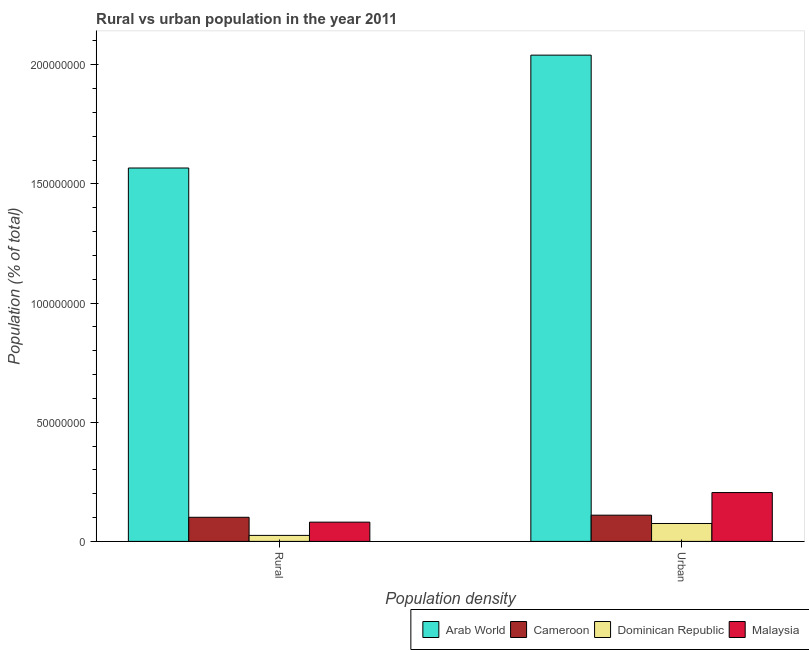How many different coloured bars are there?
Provide a short and direct response. 4. How many groups of bars are there?
Offer a terse response. 2. Are the number of bars per tick equal to the number of legend labels?
Offer a very short reply. Yes. How many bars are there on the 2nd tick from the left?
Your answer should be compact. 4. How many bars are there on the 2nd tick from the right?
Provide a succinct answer. 4. What is the label of the 1st group of bars from the left?
Provide a succinct answer. Rural. What is the urban population density in Malaysia?
Provide a succinct answer. 2.05e+07. Across all countries, what is the maximum urban population density?
Make the answer very short. 2.04e+08. Across all countries, what is the minimum urban population density?
Your response must be concise. 7.51e+06. In which country was the urban population density maximum?
Offer a terse response. Arab World. In which country was the urban population density minimum?
Give a very brief answer. Dominican Republic. What is the total urban population density in the graph?
Ensure brevity in your answer.  2.43e+08. What is the difference between the urban population density in Dominican Republic and that in Cameroon?
Provide a succinct answer. -3.49e+06. What is the difference between the rural population density in Dominican Republic and the urban population density in Cameroon?
Your response must be concise. -8.49e+06. What is the average urban population density per country?
Offer a terse response. 6.08e+07. What is the difference between the urban population density and rural population density in Malaysia?
Offer a very short reply. 1.24e+07. In how many countries, is the rural population density greater than 200000000 %?
Your answer should be very brief. 0. What is the ratio of the rural population density in Arab World to that in Dominican Republic?
Offer a very short reply. 62.33. Is the urban population density in Dominican Republic less than that in Cameroon?
Ensure brevity in your answer.  Yes. What does the 2nd bar from the left in Urban represents?
Make the answer very short. Cameroon. What does the 2nd bar from the right in Urban represents?
Provide a short and direct response. Dominican Republic. Are all the bars in the graph horizontal?
Provide a succinct answer. No. How many legend labels are there?
Offer a very short reply. 4. How are the legend labels stacked?
Provide a short and direct response. Horizontal. What is the title of the graph?
Make the answer very short. Rural vs urban population in the year 2011. Does "Montenegro" appear as one of the legend labels in the graph?
Provide a succinct answer. No. What is the label or title of the X-axis?
Provide a succinct answer. Population density. What is the label or title of the Y-axis?
Offer a terse response. Population (% of total). What is the Population (% of total) in Arab World in Rural?
Provide a succinct answer. 1.57e+08. What is the Population (% of total) of Cameroon in Rural?
Make the answer very short. 1.01e+07. What is the Population (% of total) of Dominican Republic in Rural?
Your answer should be compact. 2.51e+06. What is the Population (% of total) in Malaysia in Rural?
Provide a short and direct response. 8.08e+06. What is the Population (% of total) in Arab World in Urban?
Ensure brevity in your answer.  2.04e+08. What is the Population (% of total) of Cameroon in Urban?
Your answer should be very brief. 1.10e+07. What is the Population (% of total) of Dominican Republic in Urban?
Keep it short and to the point. 7.51e+06. What is the Population (% of total) in Malaysia in Urban?
Offer a terse response. 2.05e+07. Across all Population density, what is the maximum Population (% of total) of Arab World?
Provide a succinct answer. 2.04e+08. Across all Population density, what is the maximum Population (% of total) in Cameroon?
Your answer should be compact. 1.10e+07. Across all Population density, what is the maximum Population (% of total) in Dominican Republic?
Offer a terse response. 7.51e+06. Across all Population density, what is the maximum Population (% of total) in Malaysia?
Ensure brevity in your answer.  2.05e+07. Across all Population density, what is the minimum Population (% of total) of Arab World?
Your answer should be compact. 1.57e+08. Across all Population density, what is the minimum Population (% of total) of Cameroon?
Offer a very short reply. 1.01e+07. Across all Population density, what is the minimum Population (% of total) of Dominican Republic?
Provide a succinct answer. 2.51e+06. Across all Population density, what is the minimum Population (% of total) of Malaysia?
Ensure brevity in your answer.  8.08e+06. What is the total Population (% of total) in Arab World in the graph?
Offer a very short reply. 3.61e+08. What is the total Population (% of total) of Cameroon in the graph?
Make the answer very short. 2.11e+07. What is the total Population (% of total) of Dominican Republic in the graph?
Ensure brevity in your answer.  1.00e+07. What is the total Population (% of total) of Malaysia in the graph?
Provide a succinct answer. 2.86e+07. What is the difference between the Population (% of total) in Arab World in Rural and that in Urban?
Offer a very short reply. -4.74e+07. What is the difference between the Population (% of total) of Cameroon in Rural and that in Urban?
Give a very brief answer. -8.87e+05. What is the difference between the Population (% of total) of Dominican Republic in Rural and that in Urban?
Offer a very short reply. -5.00e+06. What is the difference between the Population (% of total) of Malaysia in Rural and that in Urban?
Provide a short and direct response. -1.24e+07. What is the difference between the Population (% of total) of Arab World in Rural and the Population (% of total) of Cameroon in Urban?
Make the answer very short. 1.46e+08. What is the difference between the Population (% of total) in Arab World in Rural and the Population (% of total) in Dominican Republic in Urban?
Provide a succinct answer. 1.49e+08. What is the difference between the Population (% of total) in Arab World in Rural and the Population (% of total) in Malaysia in Urban?
Offer a very short reply. 1.36e+08. What is the difference between the Population (% of total) in Cameroon in Rural and the Population (% of total) in Dominican Republic in Urban?
Offer a very short reply. 2.60e+06. What is the difference between the Population (% of total) of Cameroon in Rural and the Population (% of total) of Malaysia in Urban?
Provide a succinct answer. -1.04e+07. What is the difference between the Population (% of total) in Dominican Republic in Rural and the Population (% of total) in Malaysia in Urban?
Keep it short and to the point. -1.80e+07. What is the average Population (% of total) of Arab World per Population density?
Provide a short and direct response. 1.80e+08. What is the average Population (% of total) of Cameroon per Population density?
Your answer should be very brief. 1.06e+07. What is the average Population (% of total) in Dominican Republic per Population density?
Ensure brevity in your answer.  5.01e+06. What is the average Population (% of total) of Malaysia per Population density?
Your response must be concise. 1.43e+07. What is the difference between the Population (% of total) of Arab World and Population (% of total) of Cameroon in Rural?
Your answer should be very brief. 1.47e+08. What is the difference between the Population (% of total) in Arab World and Population (% of total) in Dominican Republic in Rural?
Provide a short and direct response. 1.54e+08. What is the difference between the Population (% of total) in Arab World and Population (% of total) in Malaysia in Rural?
Provide a short and direct response. 1.49e+08. What is the difference between the Population (% of total) in Cameroon and Population (% of total) in Dominican Republic in Rural?
Offer a terse response. 7.60e+06. What is the difference between the Population (% of total) of Cameroon and Population (% of total) of Malaysia in Rural?
Keep it short and to the point. 2.04e+06. What is the difference between the Population (% of total) of Dominican Republic and Population (% of total) of Malaysia in Rural?
Ensure brevity in your answer.  -5.56e+06. What is the difference between the Population (% of total) of Arab World and Population (% of total) of Cameroon in Urban?
Offer a terse response. 1.93e+08. What is the difference between the Population (% of total) of Arab World and Population (% of total) of Dominican Republic in Urban?
Provide a short and direct response. 1.97e+08. What is the difference between the Population (% of total) of Arab World and Population (% of total) of Malaysia in Urban?
Give a very brief answer. 1.84e+08. What is the difference between the Population (% of total) of Cameroon and Population (% of total) of Dominican Republic in Urban?
Keep it short and to the point. 3.49e+06. What is the difference between the Population (% of total) of Cameroon and Population (% of total) of Malaysia in Urban?
Your answer should be compact. -9.49e+06. What is the difference between the Population (% of total) of Dominican Republic and Population (% of total) of Malaysia in Urban?
Your answer should be very brief. -1.30e+07. What is the ratio of the Population (% of total) of Arab World in Rural to that in Urban?
Provide a short and direct response. 0.77. What is the ratio of the Population (% of total) in Cameroon in Rural to that in Urban?
Keep it short and to the point. 0.92. What is the ratio of the Population (% of total) in Dominican Republic in Rural to that in Urban?
Make the answer very short. 0.33. What is the ratio of the Population (% of total) in Malaysia in Rural to that in Urban?
Provide a succinct answer. 0.39. What is the difference between the highest and the second highest Population (% of total) of Arab World?
Ensure brevity in your answer.  4.74e+07. What is the difference between the highest and the second highest Population (% of total) of Cameroon?
Offer a very short reply. 8.87e+05. What is the difference between the highest and the second highest Population (% of total) of Dominican Republic?
Your answer should be very brief. 5.00e+06. What is the difference between the highest and the second highest Population (% of total) in Malaysia?
Make the answer very short. 1.24e+07. What is the difference between the highest and the lowest Population (% of total) in Arab World?
Make the answer very short. 4.74e+07. What is the difference between the highest and the lowest Population (% of total) of Cameroon?
Make the answer very short. 8.87e+05. What is the difference between the highest and the lowest Population (% of total) of Dominican Republic?
Provide a succinct answer. 5.00e+06. What is the difference between the highest and the lowest Population (% of total) in Malaysia?
Offer a very short reply. 1.24e+07. 